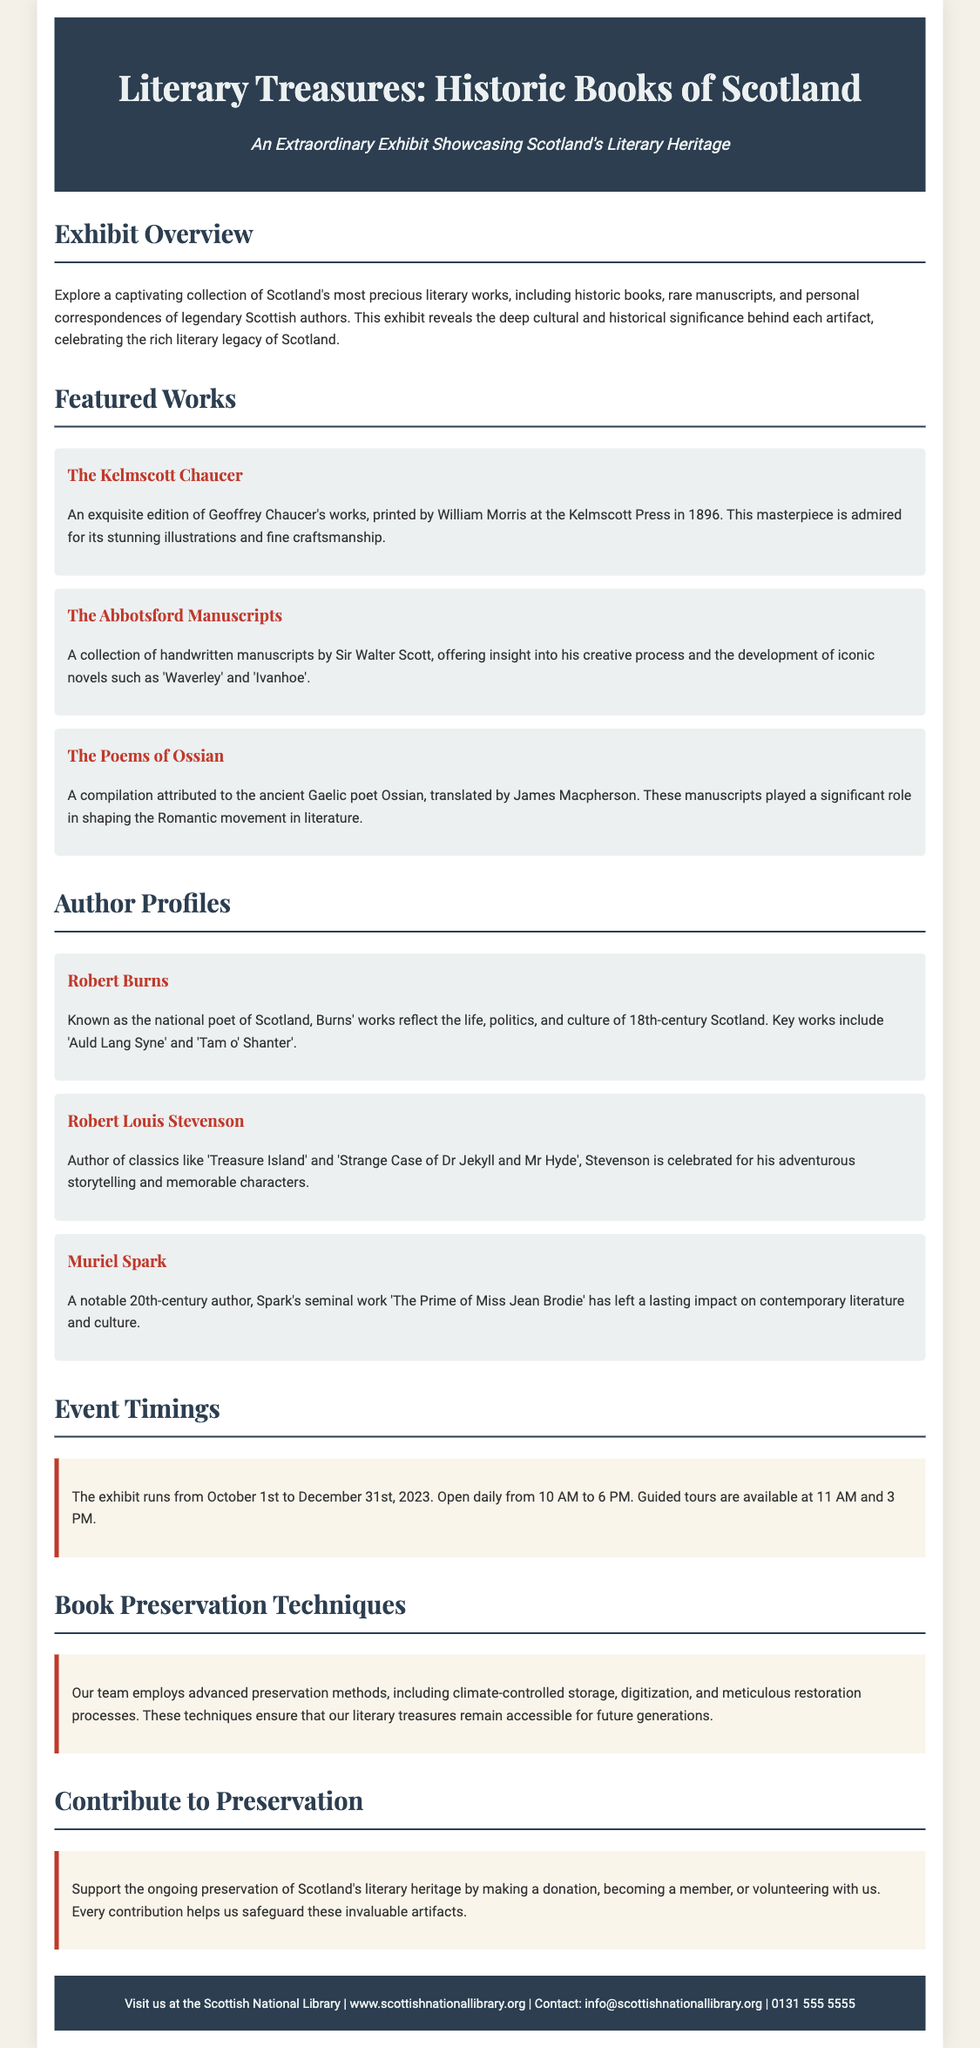What is the title of the exhibit? The title of the exhibit is clearly stated in the header of the document as "Literary Treasures: Historic Books of Scotland".
Answer: Literary Treasures: Historic Books of Scotland Who printed The Kelmscott Chaucer? The document specifies that The Kelmscott Chaucer was printed by William Morris at the Kelmscott Press.
Answer: William Morris What are the timings for guided tours? The document mentions that guided tours are available at 11 AM and 3 PM, making it easy to gather this information.
Answer: 11 AM and 3 PM What is the duration of the exhibit? The exhibit runs from October 1st to December 31st, 2023, which encapsulates the entire duration clearly.
Answer: October 1st to December 31st, 2023 Name one preservation technique mentioned. The document lists various techniques and one example given is "climate-controlled storage", which directly highlights the methods used for preservation.
Answer: Climate-controlled storage How can one contribute to preservation? The document states several ways to contribute, and one specific way mentioned is "making a donation".
Answer: Making a donation Which Scottish author is known as the national poet? The overview provided states Robert Burns is known as the national poet of Scotland, making this information easily identifiable.
Answer: Robert Burns What is the background color of the flyer? The document description indicates the background color is a soft shade, specifically stated as "#f4f1e8", which pertains to its design.
Answer: #f4f1e8 What is the purpose of the “Contribute to Preservation” section? This section highlights opportunities for public involvement, as described in the document, specifically focusing on supporting the ongoing preservation efforts.
Answer: Supporting ongoing preservation efforts 